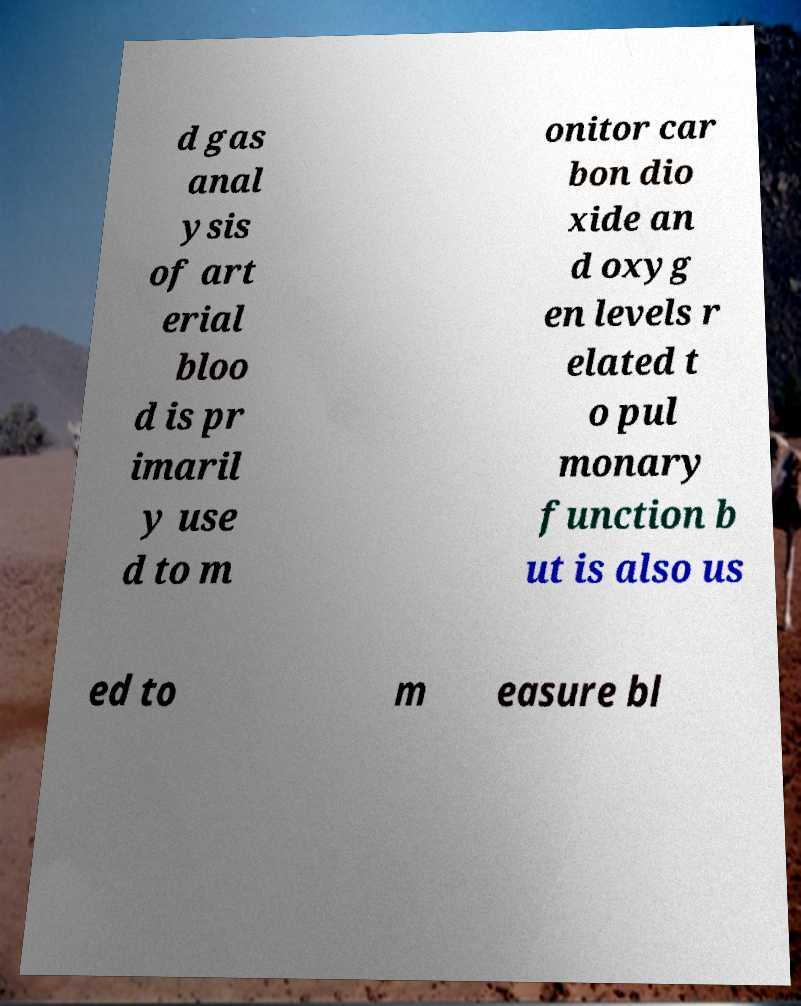Can you read and provide the text displayed in the image?This photo seems to have some interesting text. Can you extract and type it out for me? d gas anal ysis of art erial bloo d is pr imaril y use d to m onitor car bon dio xide an d oxyg en levels r elated t o pul monary function b ut is also us ed to m easure bl 